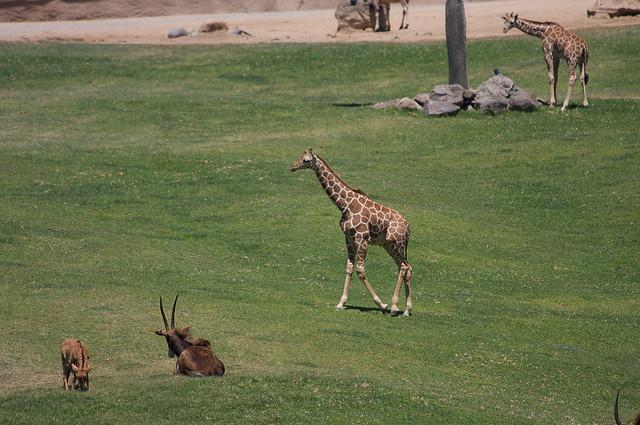How many different kinds of animals are visible?
Give a very brief answer. 2. How many animals are in the image?
Give a very brief answer. 4. How many animals are in this picture?
Give a very brief answer. 4. How many giraffes are in the photo?
Give a very brief answer. 2. 